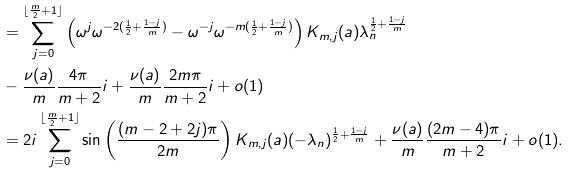Convert formula to latex. <formula><loc_0><loc_0><loc_500><loc_500>& = \sum _ { j = 0 } ^ { \lfloor \frac { m } { 2 } + 1 \rfloor } \left ( \omega ^ { j } \omega ^ { - 2 ( \frac { 1 } { 2 } + \frac { 1 - j } { m } ) } - \omega ^ { - j } \omega ^ { - m ( \frac { 1 } { 2 } + \frac { 1 - j } { m } ) } \right ) K _ { m , j } ( a ) \lambda _ { n } ^ { \frac { 1 } { 2 } + \frac { 1 - j } { m } } \\ & - \frac { \nu ( a ) } { m } \frac { 4 \pi } { m + 2 } i + \frac { \nu ( a ) } { m } \frac { 2 m \pi } { m + 2 } i + o ( 1 ) \\ & = 2 i \sum _ { j = 0 } ^ { \lfloor \frac { m } { 2 } + 1 \rfloor } \sin \left ( \frac { ( m - 2 + 2 j ) \pi } { 2 m } \right ) K _ { m , j } ( a ) ( - \lambda _ { n } ) ^ { \frac { 1 } { 2 } + \frac { 1 - j } { m } } + \frac { \nu ( a ) } { m } \frac { ( 2 m - 4 ) \pi } { m + 2 } i + o ( 1 ) .</formula> 